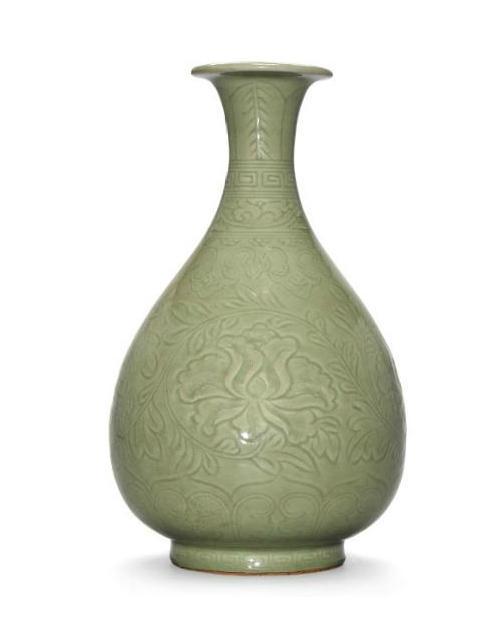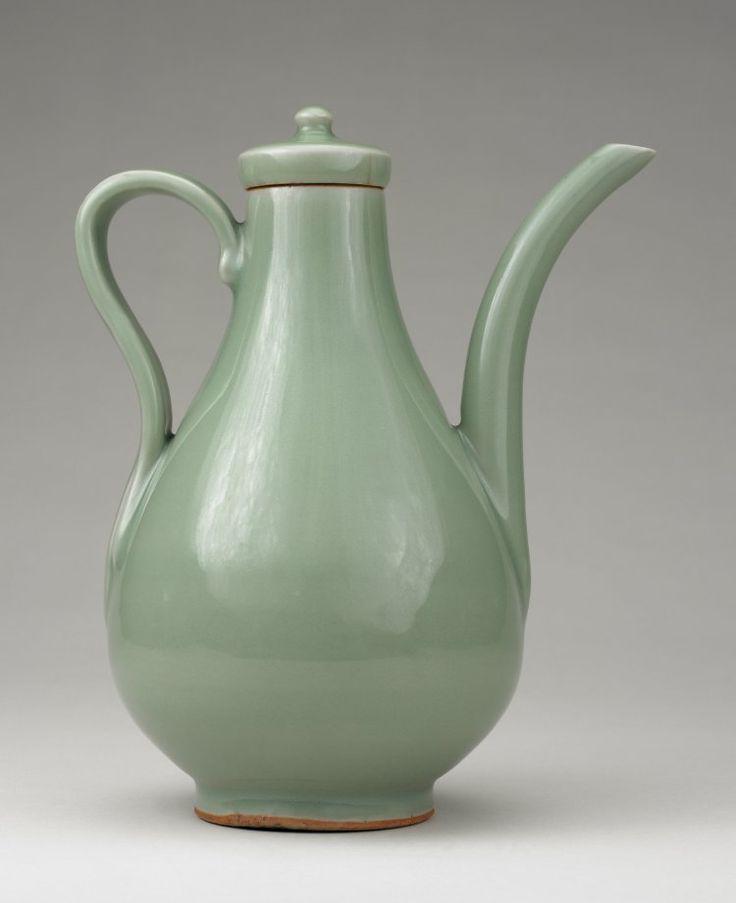The first image is the image on the left, the second image is the image on the right. Assess this claim about the two images: "An image contains a green vase that has two handles around its neck.". Correct or not? Answer yes or no. No. The first image is the image on the left, the second image is the image on the right. Evaluate the accuracy of this statement regarding the images: "One of the vases has slender handles on each side, a dimensional ribbed element, and a fluted top.". Is it true? Answer yes or no. No. 